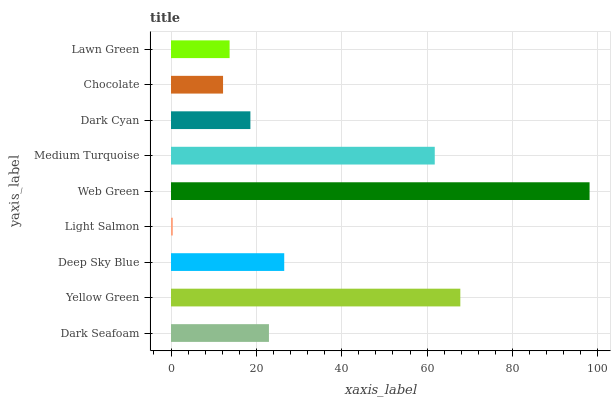Is Light Salmon the minimum?
Answer yes or no. Yes. Is Web Green the maximum?
Answer yes or no. Yes. Is Yellow Green the minimum?
Answer yes or no. No. Is Yellow Green the maximum?
Answer yes or no. No. Is Yellow Green greater than Dark Seafoam?
Answer yes or no. Yes. Is Dark Seafoam less than Yellow Green?
Answer yes or no. Yes. Is Dark Seafoam greater than Yellow Green?
Answer yes or no. No. Is Yellow Green less than Dark Seafoam?
Answer yes or no. No. Is Dark Seafoam the high median?
Answer yes or no. Yes. Is Dark Seafoam the low median?
Answer yes or no. Yes. Is Light Salmon the high median?
Answer yes or no. No. Is Yellow Green the low median?
Answer yes or no. No. 